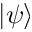Convert formula to latex. <formula><loc_0><loc_0><loc_500><loc_500>| \psi \rangle</formula> 